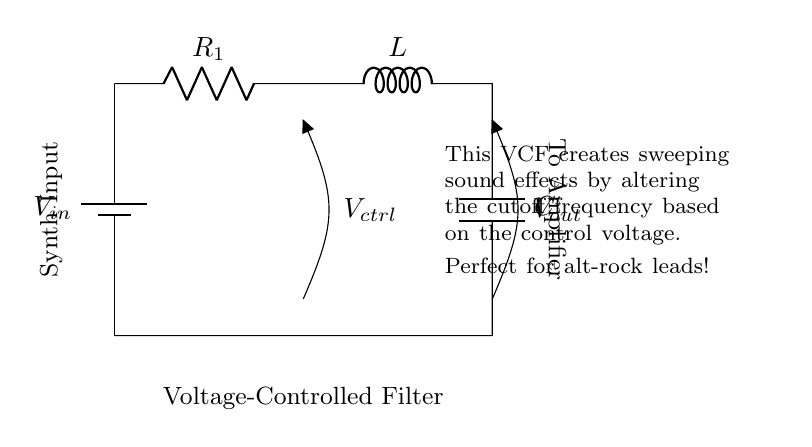What type of filter is represented in the circuit? The circuit depicts a voltage-controlled filter (VCF). This is identified by the label in the circuit diagram, which states "Voltage-Controlled Filter." The presence of a resistor, inductor, and capacitor arranged in a specific way typically signifies such a filter's role in modifying signal frequencies.
Answer: Voltage-Controlled Filter What are the components featured in this circuit? The primary components in the circuit include a resistor, an inductor, and a capacitor, as denoted by the labels R, L, and C in the diagram. These components work together to regulate the filter's response to input signals.
Answer: Resistor, Inductor, Capacitor How is the control voltage represented in the circuit? The control voltage is represented by the label \( V_{ctrl} \) in the circuit diagram. It shows where the control voltage connects within the filter, allowing external modulation to adjust the filter's properties.
Answer: \( V_{ctrl} \) What happens to the cutoff frequency when the control voltage increases? As the control voltage increases, the cutoff frequency of the filter typically rises, which means the circuit allows higher frequencies to pass through. This relationship is crucial in creating sweeping sound effects, as it responds dynamically to the varying control voltage.
Answer: Increases Which direction does the current flow in this circuit? Current flows from the battery through the resistor, then through the inductor and capacitor before returning to the battery. This path is essential for the proper operation of the filter, allowing it to modify the input signal effectively.
Answer: From battery to resistor to inductor to capacitor How would you describe the role of the capacitor in this circuit? The capacitor in this circuit works to store and release energy, helping to shape the output signal's frequency response. It interacts with the inductor and resistor to determine how frequencies are filtered, contributing significantly to the sweeping effects produced.
Answer: Energy storage and frequency shaping 